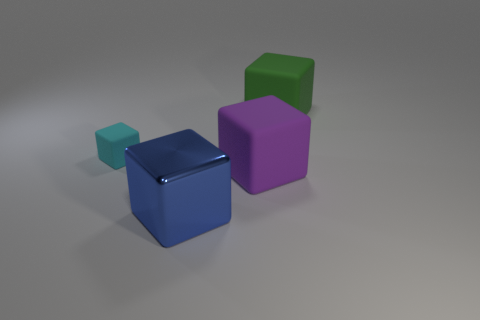How many cubes in total can we see in the image? The image displays a total of four cubes. There's a small cyan one, a slightly larger green one, an even larger blue one, and the largest cube is purple.  Are the cubes arranged in any sort of pattern? The cubes seem to be arbitrarily placed and are not following a discernible pattern. They appear to be scattered across a flat surface at various distances from one another. 